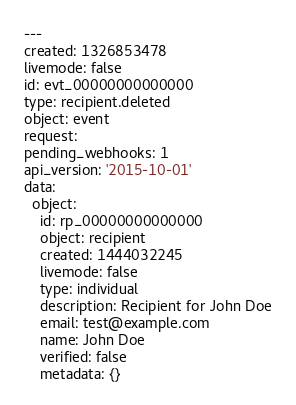<code> <loc_0><loc_0><loc_500><loc_500><_YAML_>---
created: 1326853478
livemode: false
id: evt_00000000000000
type: recipient.deleted
object: event
request: 
pending_webhooks: 1
api_version: '2015-10-01'
data:
  object:
    id: rp_00000000000000
    object: recipient
    created: 1444032245
    livemode: false
    type: individual
    description: Recipient for John Doe
    email: test@example.com
    name: John Doe
    verified: false
    metadata: {}</code> 